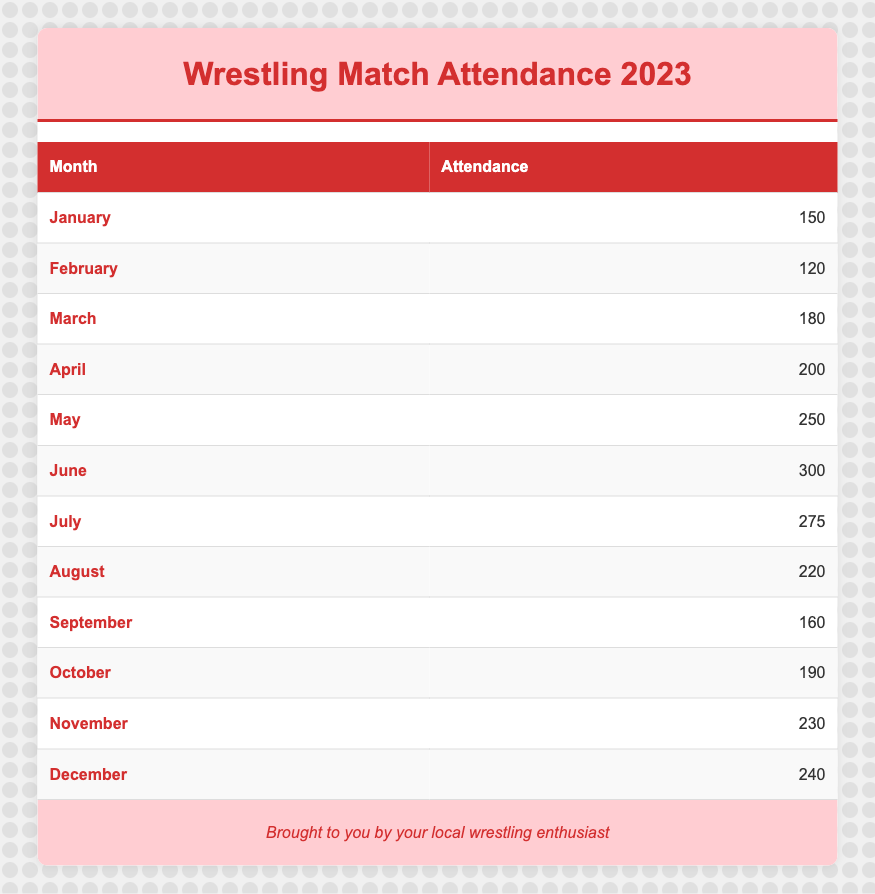What month had the highest attendance? Looking at the table, June has the highest attendance figure of 300.
Answer: June What was the attendance for April? The table lists April's attendance as 200.
Answer: 200 How many more attendees were there in May compared to February? May had 250 attendees and February had 120 attendees. The difference is 250 - 120 = 130.
Answer: 130 Is the attendance in July lower than the attendance in September? July had 275 attendees while September had 160 attendees. Therefore, this statement is false; July's attendance was higher.
Answer: No What is the average attendance for the first half of the year (January to June)? To find the average, we first sum the attendance for each month from January to June: 150 + 120 + 180 + 200 + 250 + 300 = 1200. There are 6 months in this half of the year, so we divide: 1200 / 6 = 200.
Answer: 200 What are the total attendees for the last quarter (October to December)? Adding the attendance figures for October (190), November (230), and December (240): 190 + 230 + 240 = 660.
Answer: 660 Which month had a drop in attendance compared to the previous month? The attendance dropped from June (300) to July (275). This indicates a decrease.
Answer: July How many months had attendance figures above 200? By examining the table, the months with attendance above 200 are: May (250), June (300), July (275), November (230), and December (240). This counts up to 5 months.
Answer: 5 